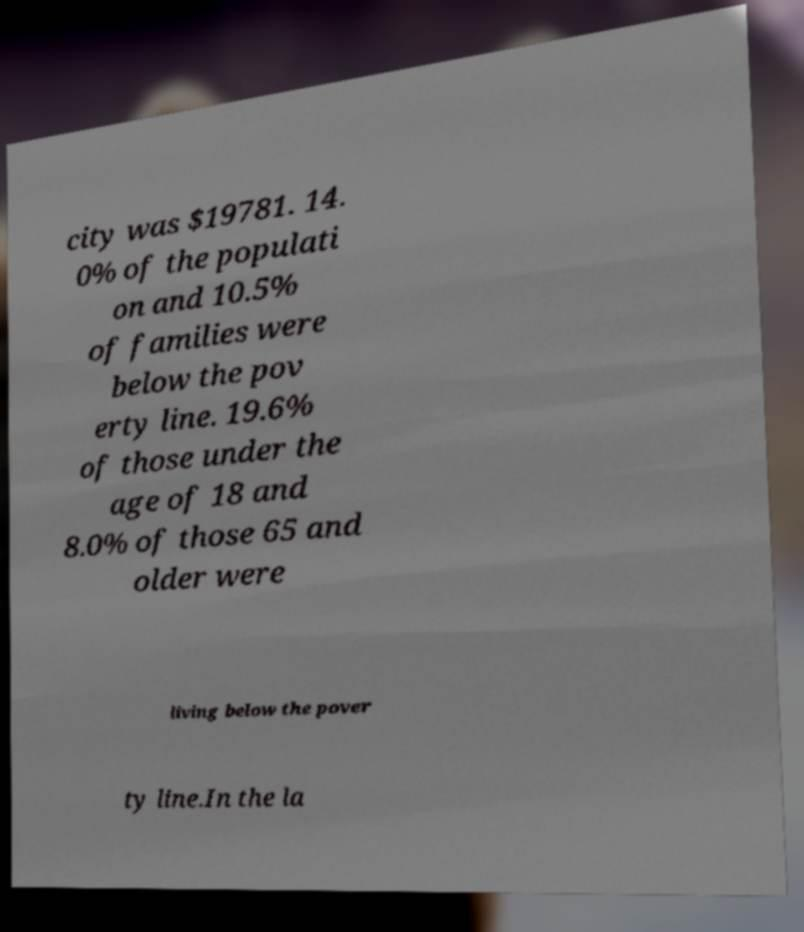There's text embedded in this image that I need extracted. Can you transcribe it verbatim? city was $19781. 14. 0% of the populati on and 10.5% of families were below the pov erty line. 19.6% of those under the age of 18 and 8.0% of those 65 and older were living below the pover ty line.In the la 